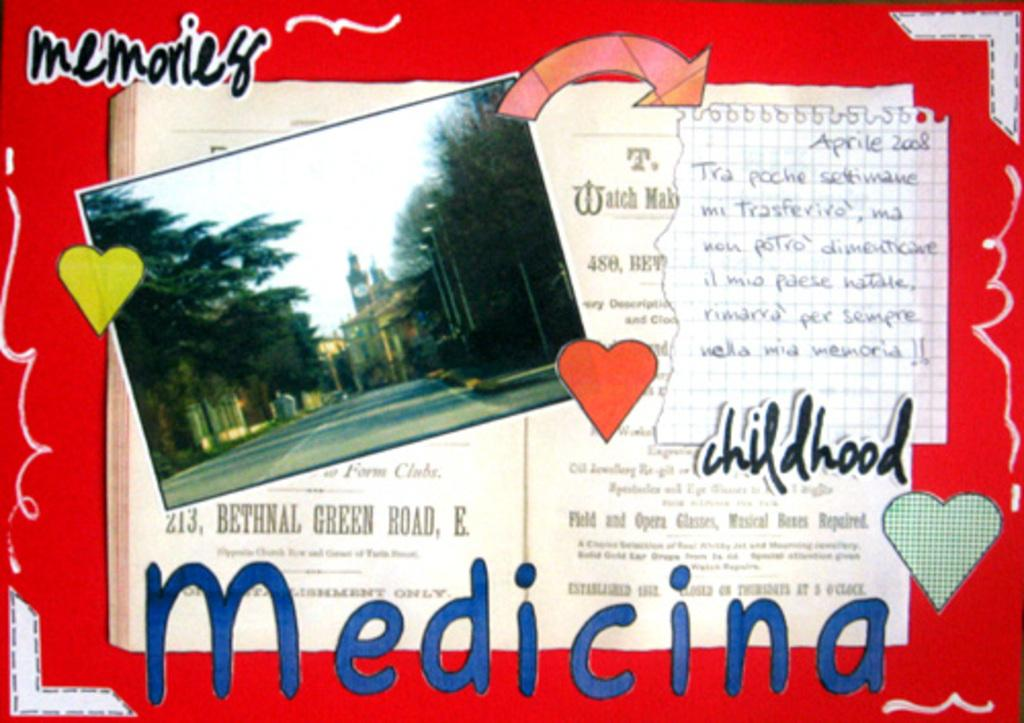<image>
Provide a brief description of the given image. A postcard in Spanish that shows a picture of a cityscape along with the words "memories", "childhood", and "Medicina". 